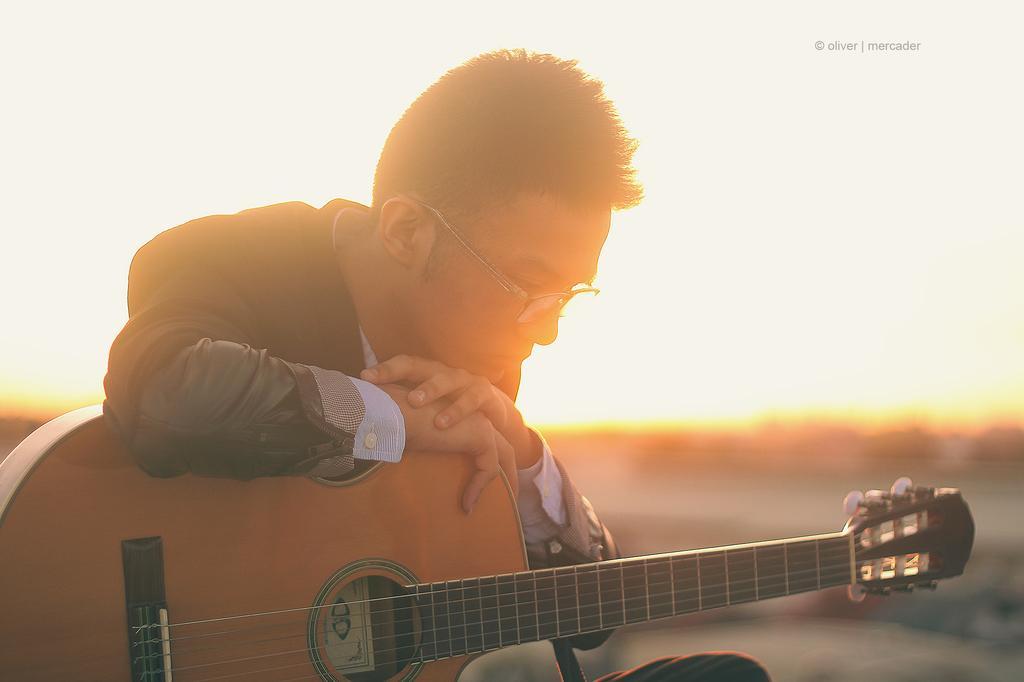In one or two sentences, can you explain what this image depicts? As we can see in the image there is a sky and a man holding guitar. 